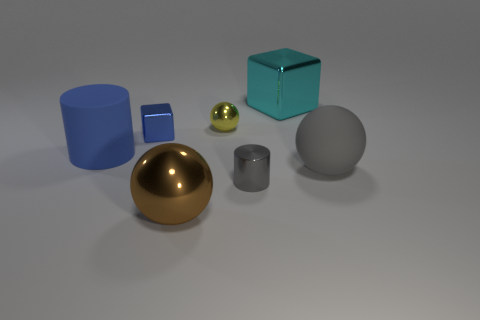What is the color of the big block behind the gray metallic thing that is in front of the yellow sphere? The big block situated behind the gray metallic object, which is in front of the yellow sphere, has a cyan color. The cyan block's calm, soothing hue contrasts nicely with the warm yellow of the sphere, creating a visually appealing composition. 